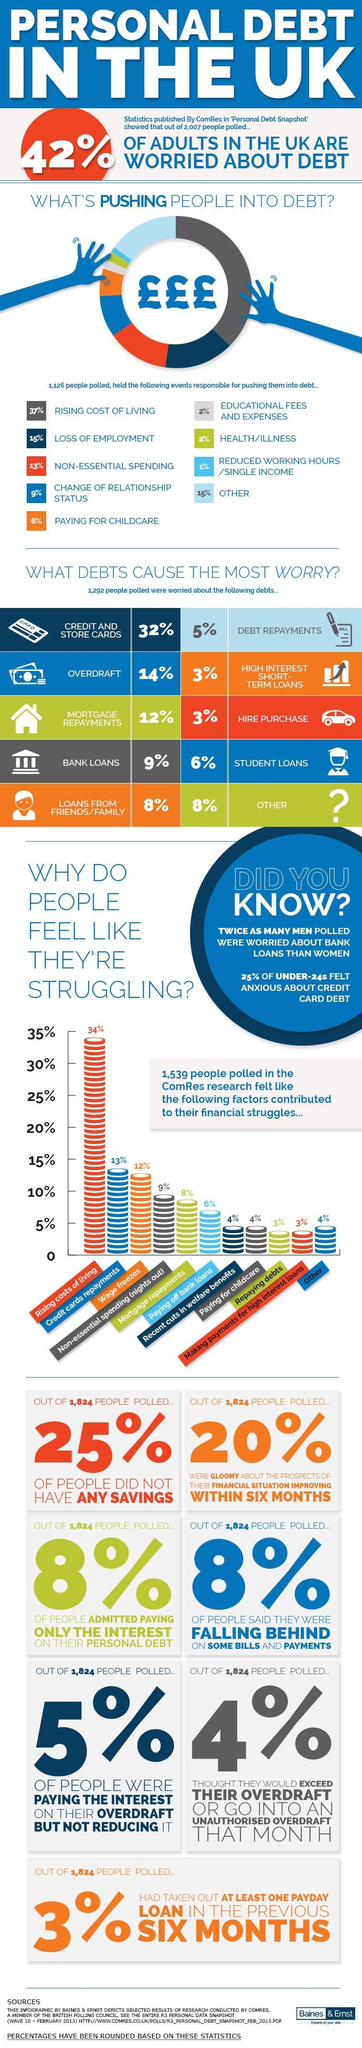Out of 1,824 people polled, what number of people did not have any savings?
Answer the question with a short phrase. 456 Who is less worried- men or women? WOMEN What percent of people were worried about mortgage repayments and bank loans? 21% What percent of adults in the UK are not worried about debt? 58% Out of 1,824 people polled, what percent were not gloomy about the prospects of improving financial situation? 80% What reason is most commonly responsible for people struggling to pay debts? Rising costs of living What are the top three reasons for debt? RISING COST OF LIVING, LOSS OF EMPLOYMENT, NON-ESSENTIAL SPENDING 